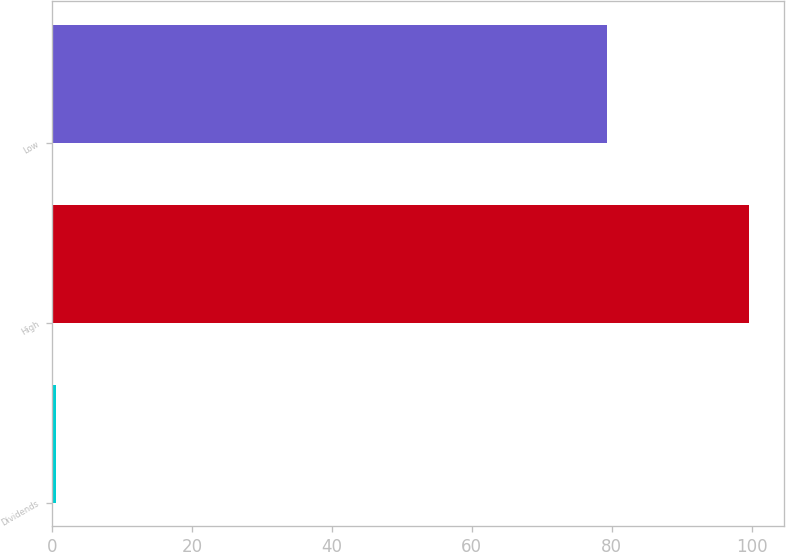Convert chart to OTSL. <chart><loc_0><loc_0><loc_500><loc_500><bar_chart><fcel>Dividends<fcel>High<fcel>Low<nl><fcel>0.55<fcel>99.71<fcel>79.31<nl></chart> 